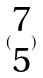Convert formula to latex. <formula><loc_0><loc_0><loc_500><loc_500>( \begin{matrix} 7 \\ 5 \end{matrix} )</formula> 